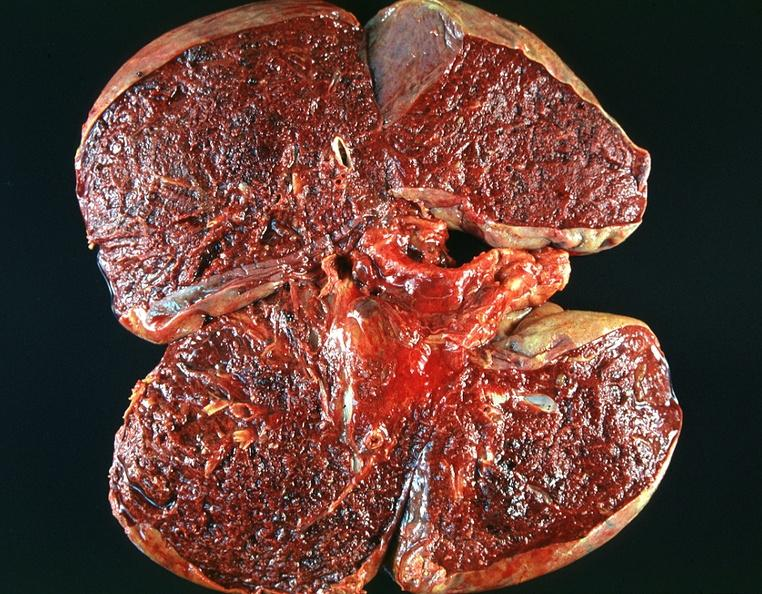does heel ulcer show lung, emphysema and pneumonia, alpha-1 antitrypsin deficiency?
Answer the question using a single word or phrase. No 